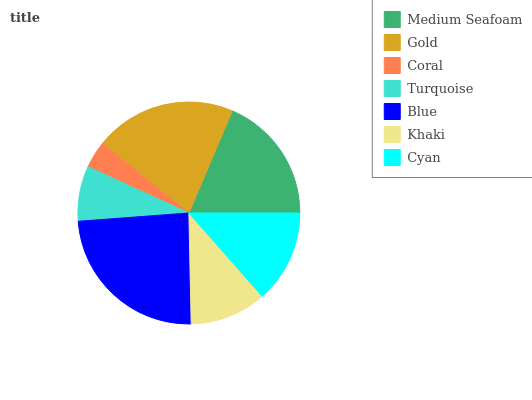Is Coral the minimum?
Answer yes or no. Yes. Is Blue the maximum?
Answer yes or no. Yes. Is Gold the minimum?
Answer yes or no. No. Is Gold the maximum?
Answer yes or no. No. Is Gold greater than Medium Seafoam?
Answer yes or no. Yes. Is Medium Seafoam less than Gold?
Answer yes or no. Yes. Is Medium Seafoam greater than Gold?
Answer yes or no. No. Is Gold less than Medium Seafoam?
Answer yes or no. No. Is Cyan the high median?
Answer yes or no. Yes. Is Cyan the low median?
Answer yes or no. Yes. Is Turquoise the high median?
Answer yes or no. No. Is Khaki the low median?
Answer yes or no. No. 